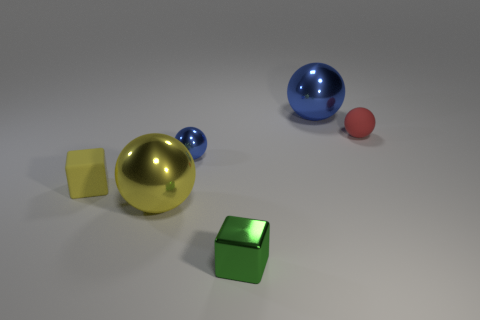What material is the thing that is the same color as the tiny rubber block?
Offer a terse response. Metal. There is a object that is the same color as the tiny shiny ball; what size is it?
Make the answer very short. Large. What is the material of the cube behind the small green metal cube?
Give a very brief answer. Rubber. Is the size of the red sphere the same as the green thing?
Offer a very short reply. Yes. What is the color of the metallic object that is behind the small yellow object and in front of the tiny red sphere?
Offer a very short reply. Blue. What is the shape of the other tiny object that is made of the same material as the red object?
Your response must be concise. Cube. What number of objects are right of the tiny yellow cube and in front of the large blue shiny object?
Keep it short and to the point. 4. There is a red rubber thing; are there any rubber balls behind it?
Provide a succinct answer. No. Do the large metal object behind the small rubber cube and the blue thing to the left of the tiny green object have the same shape?
Make the answer very short. Yes. How many things are tiny brown rubber cylinders or tiny matte balls to the right of the green thing?
Provide a succinct answer. 1. 